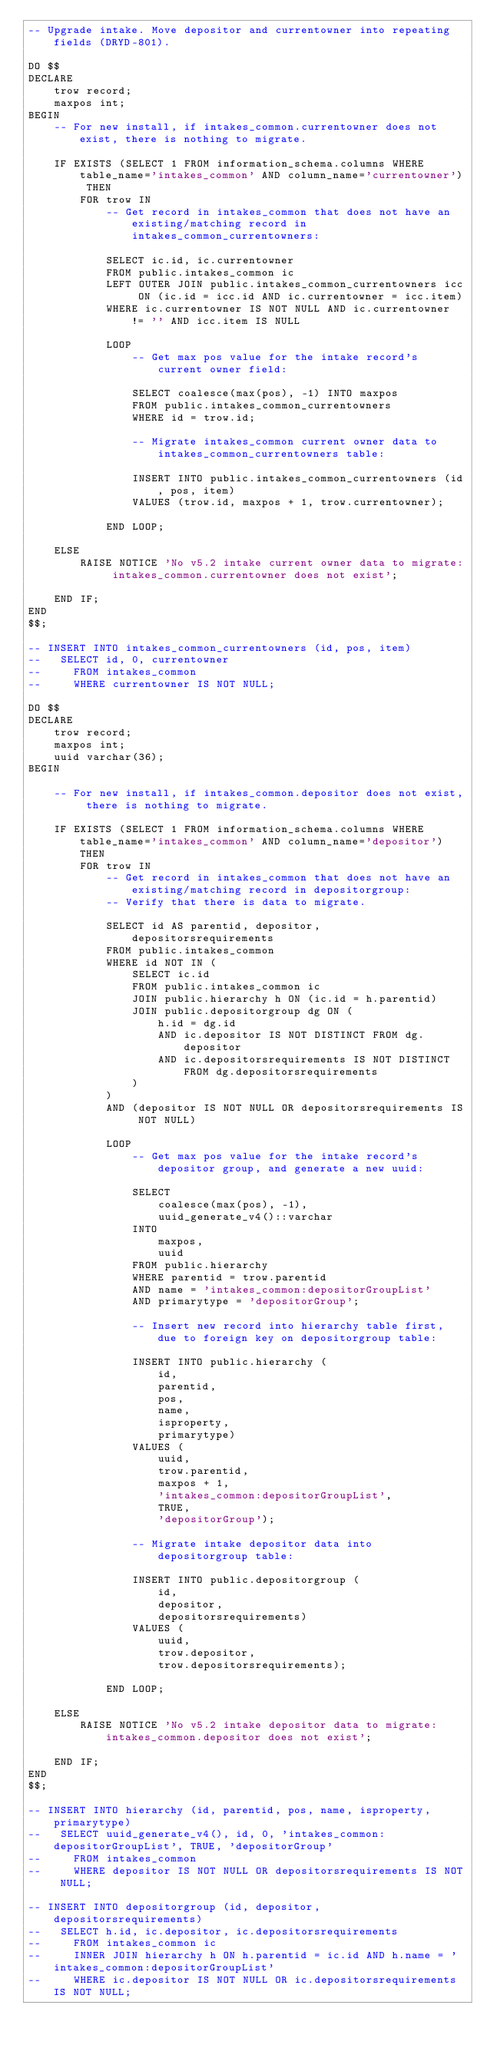<code> <loc_0><loc_0><loc_500><loc_500><_SQL_>-- Upgrade intake. Move depositor and currentowner into repeating fields (DRYD-801).

DO $$
DECLARE
    trow record;
    maxpos int;
BEGIN
    -- For new install, if intakes_common.currentowner does not exist, there is nothing to migrate.

    IF EXISTS (SELECT 1 FROM information_schema.columns WHERE table_name='intakes_common' AND column_name='currentowner') THEN
        FOR trow IN
            -- Get record in intakes_common that does not have an existing/matching record in intakes_common_currentowners:

            SELECT ic.id, ic.currentowner
            FROM public.intakes_common ic
            LEFT OUTER JOIN public.intakes_common_currentowners icc ON (ic.id = icc.id AND ic.currentowner = icc.item)
            WHERE ic.currentowner IS NOT NULL AND ic.currentowner != '' AND icc.item IS NULL

            LOOP
                -- Get max pos value for the intake record's current owner field:

                SELECT coalesce(max(pos), -1) INTO maxpos
                FROM public.intakes_common_currentowners
                WHERE id = trow.id;

                -- Migrate intakes_common current owner data to intakes_common_currentowners table:

                INSERT INTO public.intakes_common_currentowners (id, pos, item)
                VALUES (trow.id, maxpos + 1, trow.currentowner);

            END LOOP;

    ELSE
        RAISE NOTICE 'No v5.2 intake current owner data to migrate: intakes_common.currentowner does not exist';

    END IF;
END
$$;

-- INSERT INTO intakes_common_currentowners (id, pos, item)
--   SELECT id, 0, currentowner
--     FROM intakes_common
--     WHERE currentowner IS NOT NULL;

DO $$
DECLARE
    trow record;
    maxpos int;
    uuid varchar(36);
BEGIN

    -- For new install, if intakes_common.depositor does not exist, there is nothing to migrate.

    IF EXISTS (SELECT 1 FROM information_schema.columns WHERE table_name='intakes_common' AND column_name='depositor') THEN
        FOR trow IN
            -- Get record in intakes_common that does not have an existing/matching record in depositorgroup:
            -- Verify that there is data to migrate.

            SELECT id AS parentid, depositor, depositorsrequirements
            FROM public.intakes_common
            WHERE id NOT IN (
                SELECT ic.id
                FROM public.intakes_common ic
                JOIN public.hierarchy h ON (ic.id = h.parentid)
                JOIN public.depositorgroup dg ON (
                    h.id = dg.id
                    AND ic.depositor IS NOT DISTINCT FROM dg.depositor
                    AND ic.depositorsrequirements IS NOT DISTINCT FROM dg.depositorsrequirements
                )
            )
            AND (depositor IS NOT NULL OR depositorsrequirements IS NOT NULL)

            LOOP
                -- Get max pos value for the intake record's depositor group, and generate a new uuid:

                SELECT
                    coalesce(max(pos), -1),
                    uuid_generate_v4()::varchar
                INTO
                    maxpos,
                    uuid
                FROM public.hierarchy
                WHERE parentid = trow.parentid
                AND name = 'intakes_common:depositorGroupList'
                AND primarytype = 'depositorGroup';

                -- Insert new record into hierarchy table first, due to foreign key on depositorgroup table:

                INSERT INTO public.hierarchy (
                    id,
                    parentid,
                    pos,
                    name,
                    isproperty,
                    primarytype)
                VALUES (
                    uuid,
                    trow.parentid,
                    maxpos + 1,
                    'intakes_common:depositorGroupList',
                    TRUE,
                    'depositorGroup');

                -- Migrate intake depositor data into depositorgroup table:

                INSERT INTO public.depositorgroup (
                    id,
                    depositor,
                    depositorsrequirements)
                VALUES (
                    uuid,
                    trow.depositor,
                    trow.depositorsrequirements);

            END LOOP;

    ELSE
        RAISE NOTICE 'No v5.2 intake depositor data to migrate: intakes_common.depositor does not exist';

    END IF;
END
$$;

-- INSERT INTO hierarchy (id, parentid, pos, name, isproperty, primarytype)
--   SELECT uuid_generate_v4(), id, 0, 'intakes_common:depositorGroupList', TRUE, 'depositorGroup'
--     FROM intakes_common
--     WHERE depositor IS NOT NULL OR depositorsrequirements IS NOT NULL;

-- INSERT INTO depositorgroup (id, depositor, depositorsrequirements)
--   SELECT h.id, ic.depositor, ic.depositorsrequirements
--     FROM intakes_common ic
--     INNER JOIN hierarchy h ON h.parentid = ic.id AND h.name = 'intakes_common:depositorGroupList'
--     WHERE ic.depositor IS NOT NULL OR ic.depositorsrequirements IS NOT NULL;
</code> 